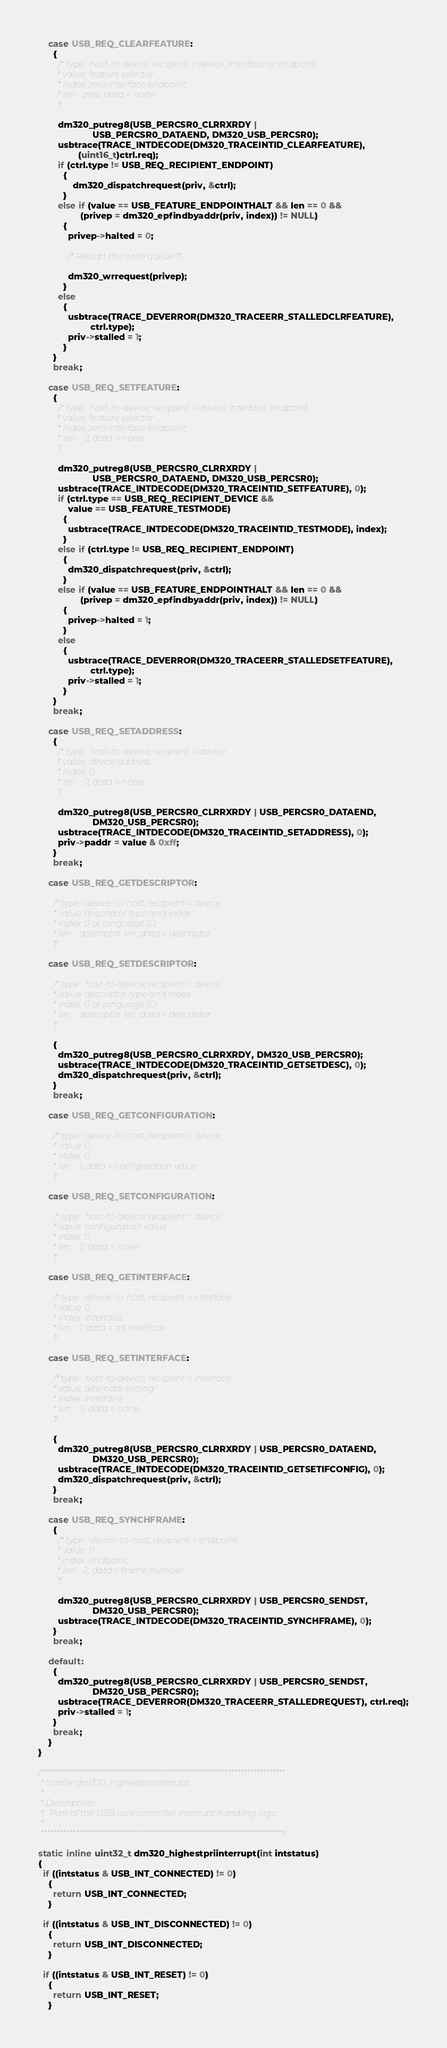<code> <loc_0><loc_0><loc_500><loc_500><_C_>
    case USB_REQ_CLEARFEATURE:
      {
        /* type:  host-to device; recipient = device, interface or endpoint
         * value: feature selector
         * index: zero interface endpoint;
         * len:   zero, data = none
         */

        dm320_putreg8(USB_PERCSR0_CLRRXRDY |
                      USB_PERCSR0_DATAEND, DM320_USB_PERCSR0);
        usbtrace(TRACE_INTDECODE(DM320_TRACEINTID_CLEARFEATURE),
                (uint16_t)ctrl.req);
        if (ctrl.type != USB_REQ_RECIPIENT_ENDPOINT)
          {
              dm320_dispatchrequest(priv, &ctrl);
          }
        else if (value == USB_FEATURE_ENDPOINTHALT && len == 0 &&
                 (privep = dm320_epfindbyaddr(priv, index)) != NULL)
          {
            privep->halted = 0;

            /* Restart the write queue */

            dm320_wrrequest(privep);
          }
        else
          {
            usbtrace(TRACE_DEVERROR(DM320_TRACEERR_STALLEDCLRFEATURE),
                     ctrl.type);
            priv->stalled = 1;
          }
      }
      break;

    case USB_REQ_SETFEATURE:
      {
        /* type:  host-to-device; recipient = device, interface, endpoint
         * value: feature selector
         * index: zero interface endpoint;
         * len:   0; data = none
         */

        dm320_putreg8(USB_PERCSR0_CLRRXRDY |
                      USB_PERCSR0_DATAEND, DM320_USB_PERCSR0);
        usbtrace(TRACE_INTDECODE(DM320_TRACEINTID_SETFEATURE), 0);
        if (ctrl.type == USB_REQ_RECIPIENT_DEVICE &&
            value == USB_FEATURE_TESTMODE)
          {
            usbtrace(TRACE_INTDECODE(DM320_TRACEINTID_TESTMODE), index);
          }
        else if (ctrl.type != USB_REQ_RECIPIENT_ENDPOINT)
          {
            dm320_dispatchrequest(priv, &ctrl);
          }
        else if (value == USB_FEATURE_ENDPOINTHALT && len == 0 &&
                 (privep = dm320_epfindbyaddr(priv, index)) != NULL)
          {
            privep->halted = 1;
          }
        else
          {
            usbtrace(TRACE_DEVERROR(DM320_TRACEERR_STALLEDSETFEATURE),
                     ctrl.type);
            priv->stalled = 1;
          }
      }
      break;

    case USB_REQ_SETADDRESS:
      {
        /* type:  host-to-device; recipient = device
         * value: device address
         * index: 0
         * len:   0; data = none
         */

        dm320_putreg8(USB_PERCSR0_CLRRXRDY | USB_PERCSR0_DATAEND,
                      DM320_USB_PERCSR0);
        usbtrace(TRACE_INTDECODE(DM320_TRACEINTID_SETADDRESS), 0);
        priv->paddr = value & 0xff;
      }
      break;

    case USB_REQ_GETDESCRIPTOR:

      /* type:  device-to-host; recipient = device
       * value: descriptor type and index
       * index: 0 or language ID;
       * len:   descriptor len; data = descriptor
       */

    case USB_REQ_SETDESCRIPTOR:

      /* type:  host-to-device; recipient = device
       * value: descriptor type and index
       * index: 0 or language ID;
       * len:   descriptor len; data = descriptor
       */

      {
        dm320_putreg8(USB_PERCSR0_CLRRXRDY, DM320_USB_PERCSR0);
        usbtrace(TRACE_INTDECODE(DM320_TRACEINTID_GETSETDESC), 0);
        dm320_dispatchrequest(priv, &ctrl);
      }
      break;

    case USB_REQ_GETCONFIGURATION:

      /* type:  device-to-host; recipient = device
       * value: 0;
       * index: 0;
       * len:   1; data = configuration value
       */

    case USB_REQ_SETCONFIGURATION:

      /* type:  host-to-device; recipient = device
       * value: configuration value
       * index: 0;
       * len:   0; data = none
       */

    case USB_REQ_GETINTERFACE:

      /* type:  device-to-host; recipient = interface
       * value: 0
       * index: interface;
       * len:   1; data = alt interface
       */

    case USB_REQ_SETINTERFACE:

      /* type:  host-to-device; recipient = interface
       * value: alternate setting
       * index: interface;
       * len:   0; data = none
       */

      {
        dm320_putreg8(USB_PERCSR0_CLRRXRDY | USB_PERCSR0_DATAEND,
                      DM320_USB_PERCSR0);
        usbtrace(TRACE_INTDECODE(DM320_TRACEINTID_GETSETIFCONFIG), 0);
        dm320_dispatchrequest(priv, &ctrl);
      }
      break;

    case USB_REQ_SYNCHFRAME:
      {
        /* type:  device-to-host; recipient = endpoint
         * value: 0
         * index: endpoint;
         * len:   2; data = frame number
         */

        dm320_putreg8(USB_PERCSR0_CLRRXRDY | USB_PERCSR0_SENDST,
                      DM320_USB_PERCSR0);
        usbtrace(TRACE_INTDECODE(DM320_TRACEINTID_SYNCHFRAME), 0);
      }
      break;

    default:
      {
        dm320_putreg8(USB_PERCSR0_CLRRXRDY | USB_PERCSR0_SENDST,
                      DM320_USB_PERCSR0);
        usbtrace(TRACE_DEVERROR(DM320_TRACEERR_STALLEDREQUEST), ctrl.req);
        priv->stalled = 1;
      }
      break;
    }
}

/****************************************************************************
 * Name: dm320_highestpriinterrupt
 *
 * Description:
 *   Part of the USB core controller interrupt handling logic
 *
 ****************************************************************************/

static inline uint32_t dm320_highestpriinterrupt(int intstatus)
{
  if ((intstatus & USB_INT_CONNECTED) != 0)
    {
      return USB_INT_CONNECTED;
    }

  if ((intstatus & USB_INT_DISCONNECTED) != 0)
    {
      return USB_INT_DISCONNECTED;
    }

  if ((intstatus & USB_INT_RESET) != 0)
    {
      return USB_INT_RESET;
    }
</code> 